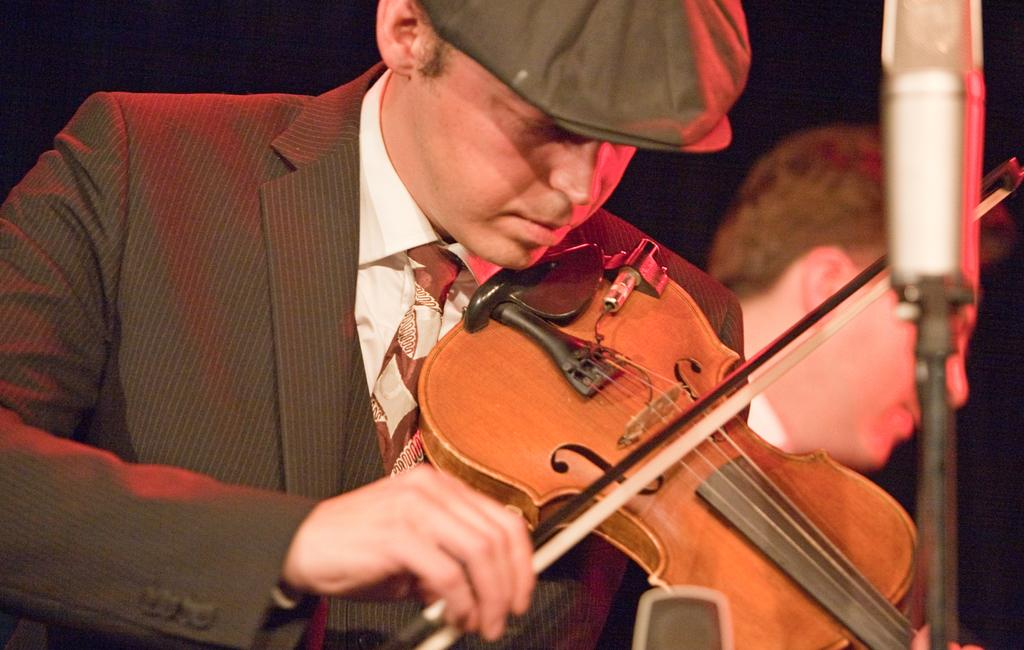How many people are in the image? There are two people in the image. What is one person doing in the image? One person is playing a violin. What object is in front of the person playing the violin? There is a microphone in front of the person playing the violin. Where is the notebook located in the image? There is no notebook present in the image. Can you see any faucets in the image? There are no faucets present in the image. 